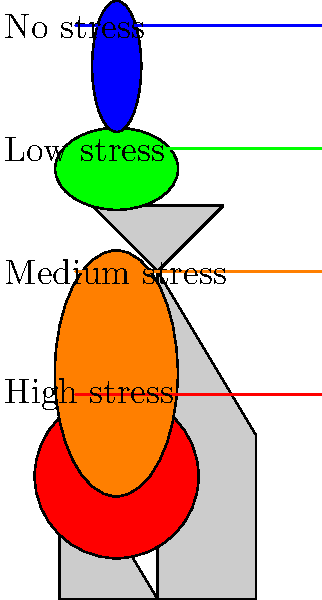Based on the color-coded body diagram used to visualize stress levels in children, which area of the body is represented as experiencing the highest level of stress? To answer this question, we need to analyze the color-coded body diagram:

1. First, observe the legend on the right side of the diagram:
   - Red represents "High stress"
   - Orange represents "Medium stress"
   - Green represents "Low stress"
   - Blue represents "No stress"

2. Now, examine the colored areas on the body diagram:
   - The head area is colored red
   - The chest area is colored orange
   - The stomach area is colored green
   - The legs area is colored blue

3. Comparing the colored areas to the legend, we can see that:
   - The head (red) corresponds to "High stress"
   - The chest (orange) corresponds to "Medium stress"
   - The stomach (green) corresponds to "Low stress"
   - The legs (blue) correspond to "No stress"

4. The question asks for the area experiencing the highest level of stress.

5. Based on our analysis, the red-colored area (the head) represents the highest level of stress according to the legend.

Therefore, the head is the area of the body represented as experiencing the highest level of stress in this color-coded body diagram.
Answer: Head 